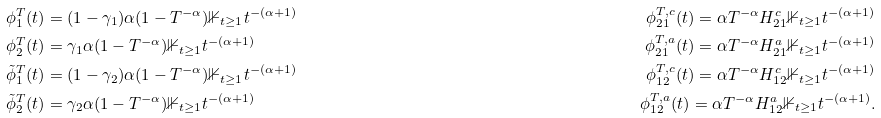Convert formula to latex. <formula><loc_0><loc_0><loc_500><loc_500>\phi ^ { T } _ { 1 } ( t ) & = ( 1 - \gamma _ { 1 } ) \alpha ( 1 - T ^ { - \alpha } ) \mathbb { 1 } _ { t \geq 1 } t ^ { - ( \alpha + 1 ) } & \phi ^ { T , c } _ { 2 1 } ( t ) = \alpha T ^ { - \alpha } H ^ { c } _ { 2 1 } \mathbb { 1 } _ { t \geq 1 } t ^ { - ( \alpha + 1 ) } \\ \phi ^ { T } _ { 2 } ( t ) & = \gamma _ { 1 } \alpha ( 1 - T ^ { - \alpha } ) \mathbb { 1 } _ { t \geq 1 } t ^ { - ( \alpha + 1 ) } & \phi ^ { T , a } _ { 2 1 } ( t ) = \alpha T ^ { - \alpha } H ^ { a } _ { 2 1 } \mathbb { 1 } _ { t \geq 1 } t ^ { - ( \alpha + 1 ) } \\ \tilde { \phi } ^ { T } _ { 1 } ( t ) & = ( 1 - \gamma _ { 2 } ) \alpha ( 1 - T ^ { - \alpha } ) \mathbb { 1 } _ { t \geq 1 } t ^ { - ( \alpha + 1 ) } & \phi ^ { T , c } _ { 1 2 } ( t ) = \alpha T ^ { - \alpha } H ^ { c } _ { 1 2 } \mathbb { 1 } _ { t \geq 1 } t ^ { - ( \alpha + 1 ) } \\ \tilde { \phi } ^ { T } _ { 2 } ( t ) & = \gamma _ { 2 } \alpha ( 1 - T ^ { - \alpha } ) \mathbb { 1 } _ { t \geq 1 } t ^ { - ( \alpha + 1 ) } & \phi ^ { T , a } _ { 1 2 } ( t ) = \alpha T ^ { - \alpha } H ^ { a } _ { 1 2 } \mathbb { 1 } _ { t \geq 1 } t ^ { - ( \alpha + 1 ) } .</formula> 